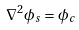Convert formula to latex. <formula><loc_0><loc_0><loc_500><loc_500>\nabla ^ { 2 } \phi _ { s } = \phi _ { c }</formula> 